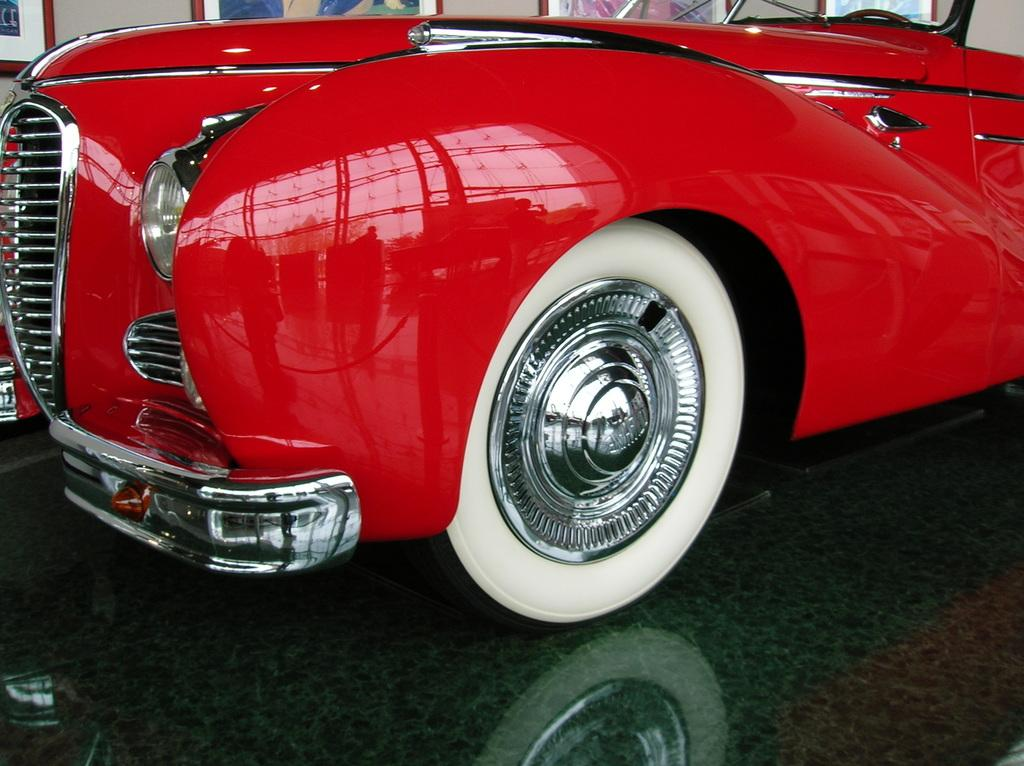What is the color of the vehicle in the image? The vehicle in the image is red. What is the color of one of the tires on the vehicle? The vehicle has a white tire. What can be seen on the wall in the background of the image? There are photo frames attached to the wall in the background of the image. What type of key is used to unlock the vehicle in the image? There is no mention of a key in the image, so it is not possible to determine what type of key might be used to unlock the vehicle. 